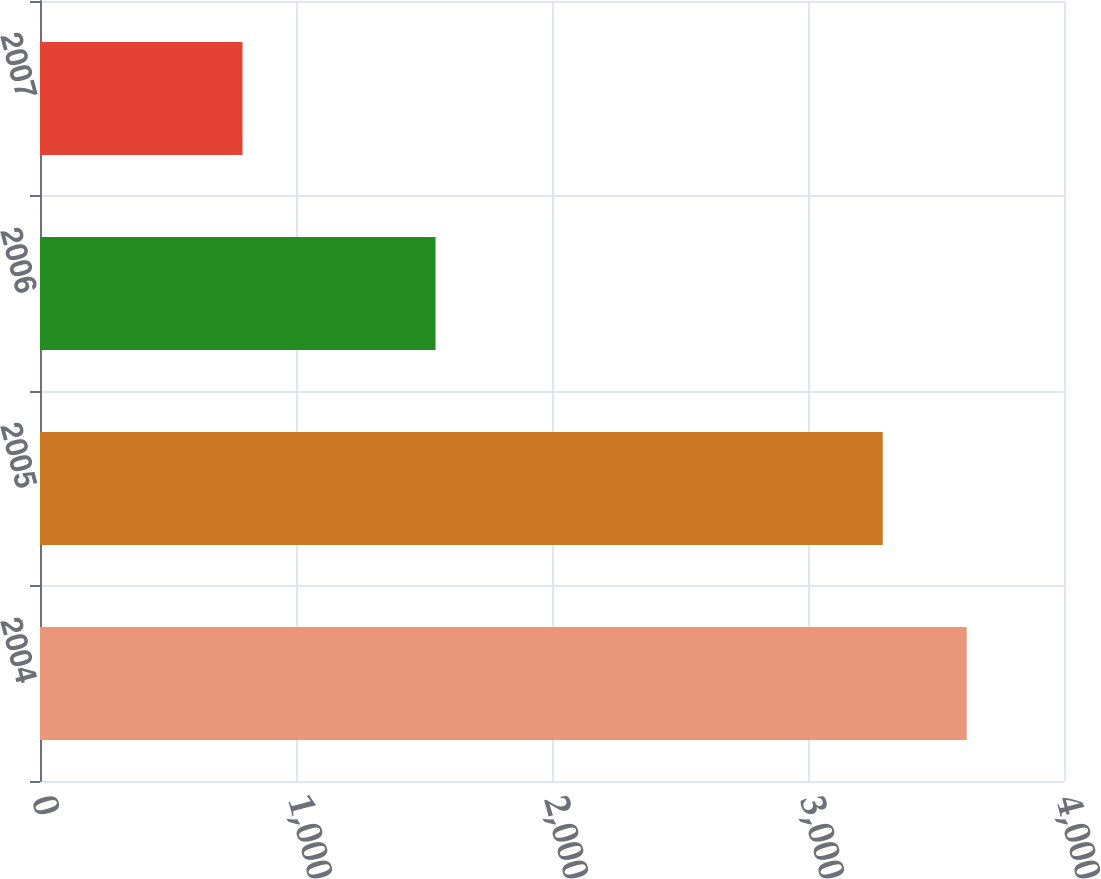Convert chart. <chart><loc_0><loc_0><loc_500><loc_500><bar_chart><fcel>2004<fcel>2005<fcel>2006<fcel>2007<nl><fcel>3620<fcel>3292<fcel>1545<fcel>791<nl></chart> 